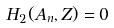Convert formula to latex. <formula><loc_0><loc_0><loc_500><loc_500>H _ { 2 } ( A _ { n } , Z ) = 0</formula> 